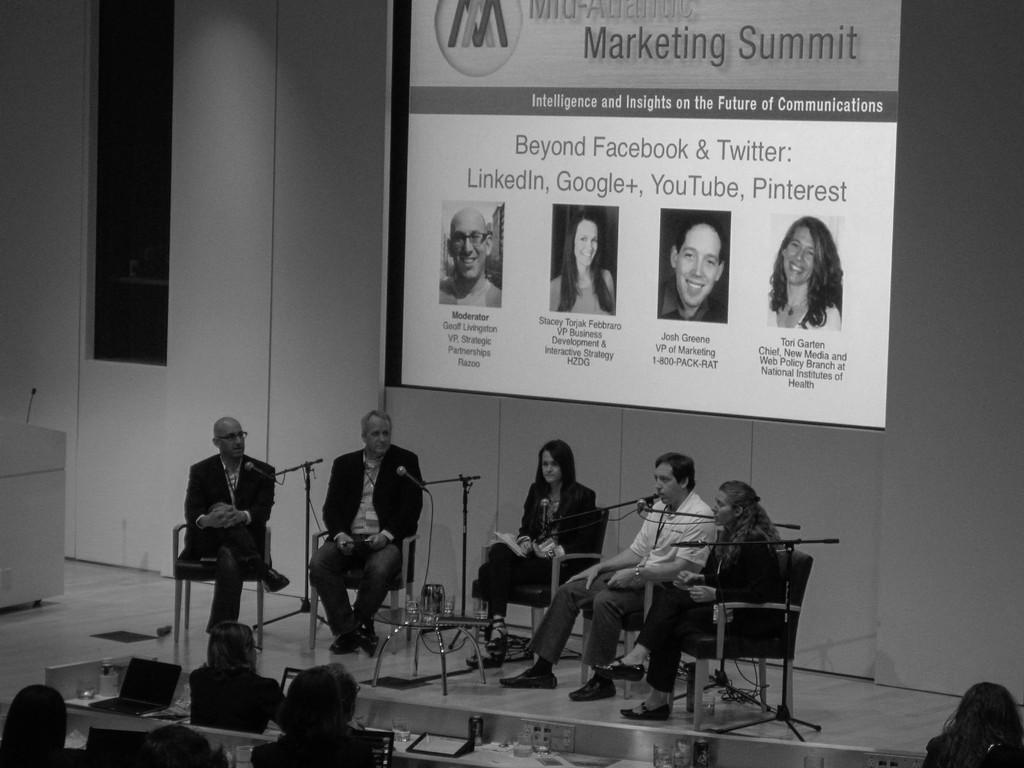Could you give a brief overview of what you see in this image? This is a black and white image where we can see men and women are sitting on the chairs. In front of them, we can see the stands, mics and a table. On the table, we can see glasses and jug. At the bottom of the image, we can see people, tables and electronic devices. At the top of the image, we can see a screen and the wall. We can see a podium on the left side of the image. 